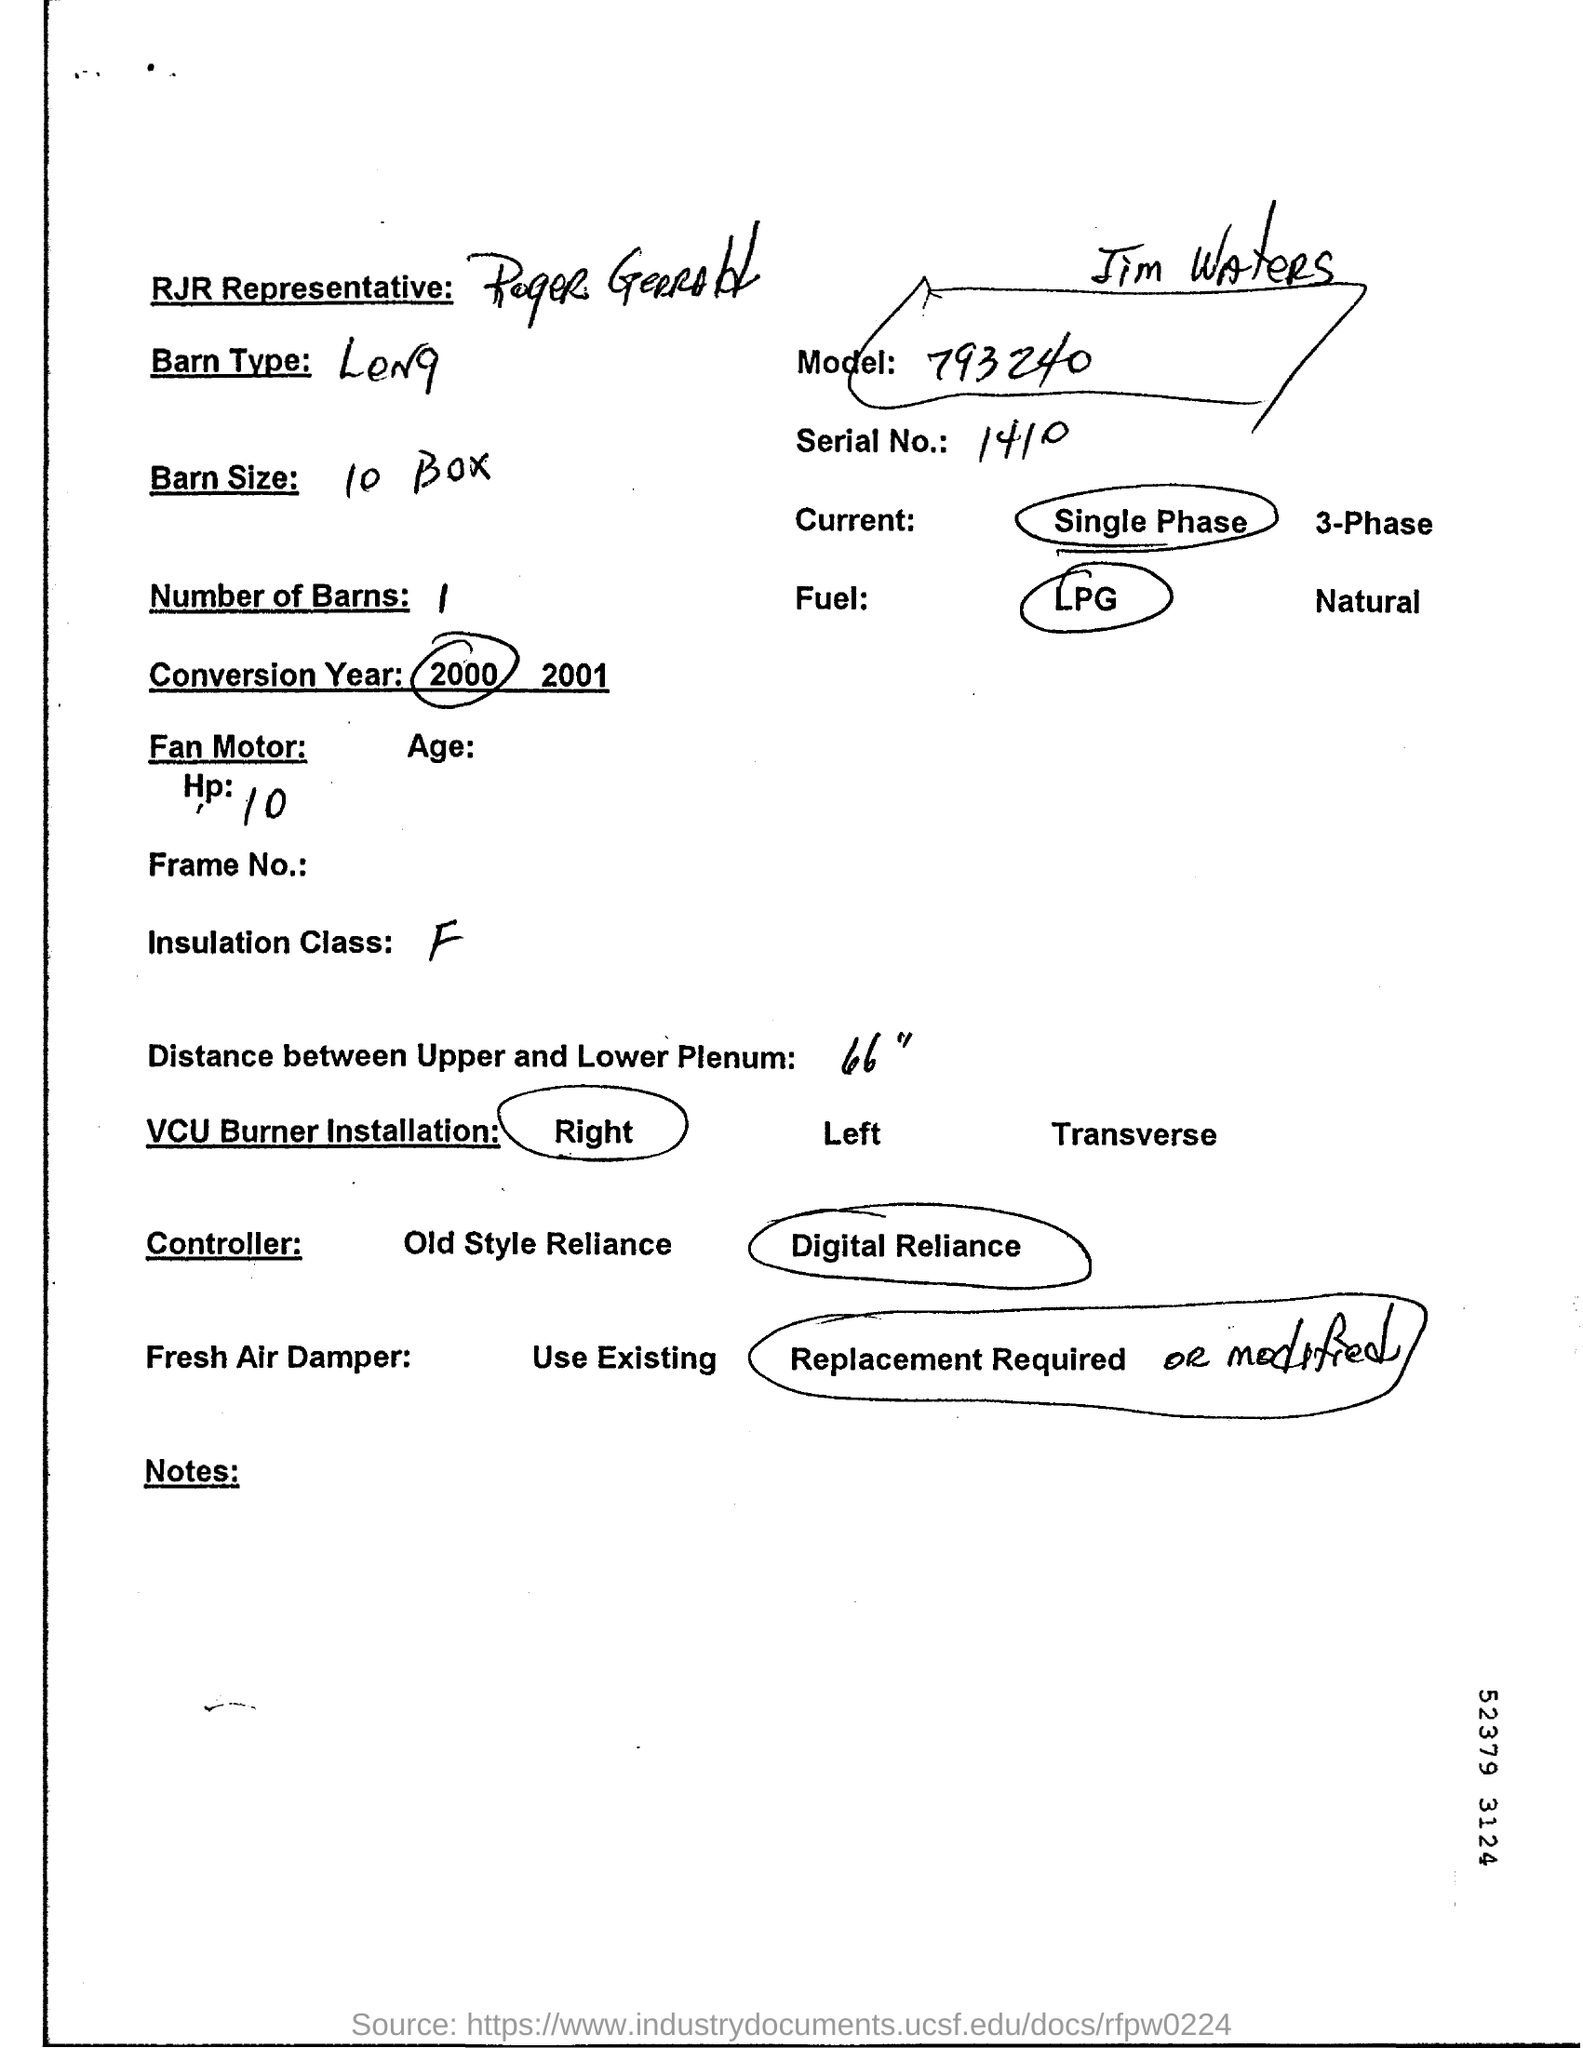What is the Serial No?
Provide a succinct answer. 1410. What is the model number?
Provide a succinct answer. 793240. What is the barn size?
Provide a short and direct response. 10 Box. What is the Distance between Upper and Lower Plenum?
Provide a succinct answer. 66". 